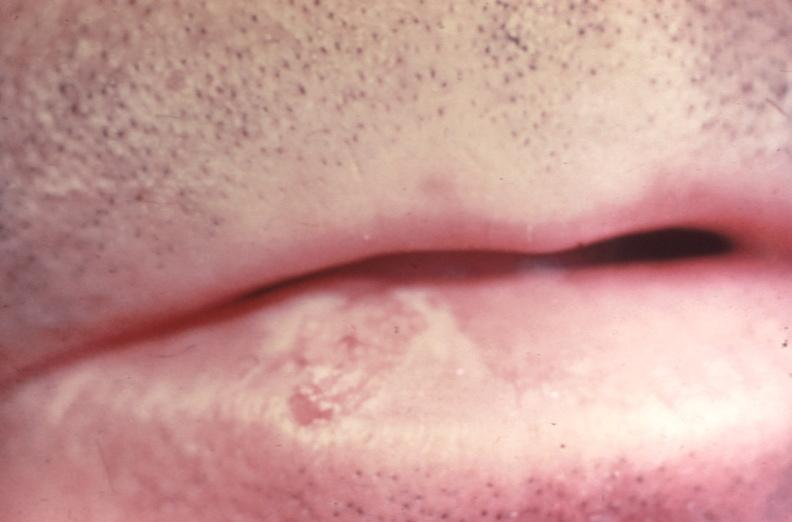s embryo-fetus present?
Answer the question using a single word or phrase. No 